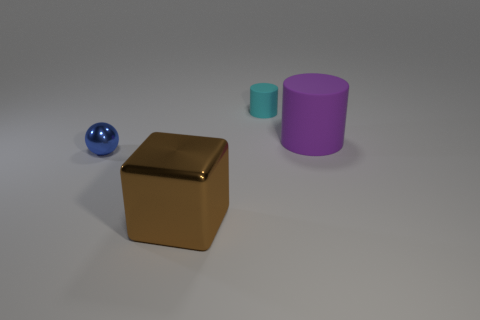Add 2 big gray things. How many objects exist? 6 Subtract all blocks. How many objects are left? 3 Subtract 1 balls. How many balls are left? 0 Subtract all purple cylinders. How many cylinders are left? 1 Subtract 1 brown cubes. How many objects are left? 3 Subtract all purple cylinders. Subtract all cyan blocks. How many cylinders are left? 1 Subtract all purple things. Subtract all brown metallic cylinders. How many objects are left? 3 Add 2 large metallic objects. How many large metallic objects are left? 3 Add 4 big blue blocks. How many big blue blocks exist? 4 